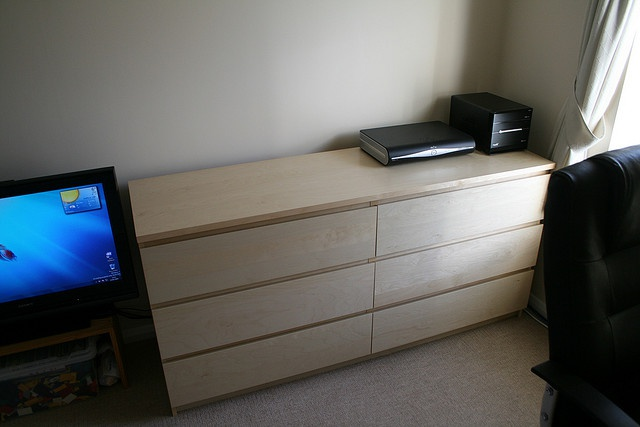Describe the objects in this image and their specific colors. I can see chair in black and gray tones and tv in black, lightblue, blue, and darkblue tones in this image. 